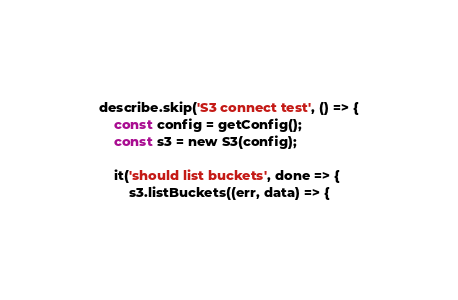Convert code to text. <code><loc_0><loc_0><loc_500><loc_500><_JavaScript_>describe.skip('S3 connect test', () => {
    const config = getConfig();
    const s3 = new S3(config);

    it('should list buckets', done => {
        s3.listBuckets((err, data) => {</code> 